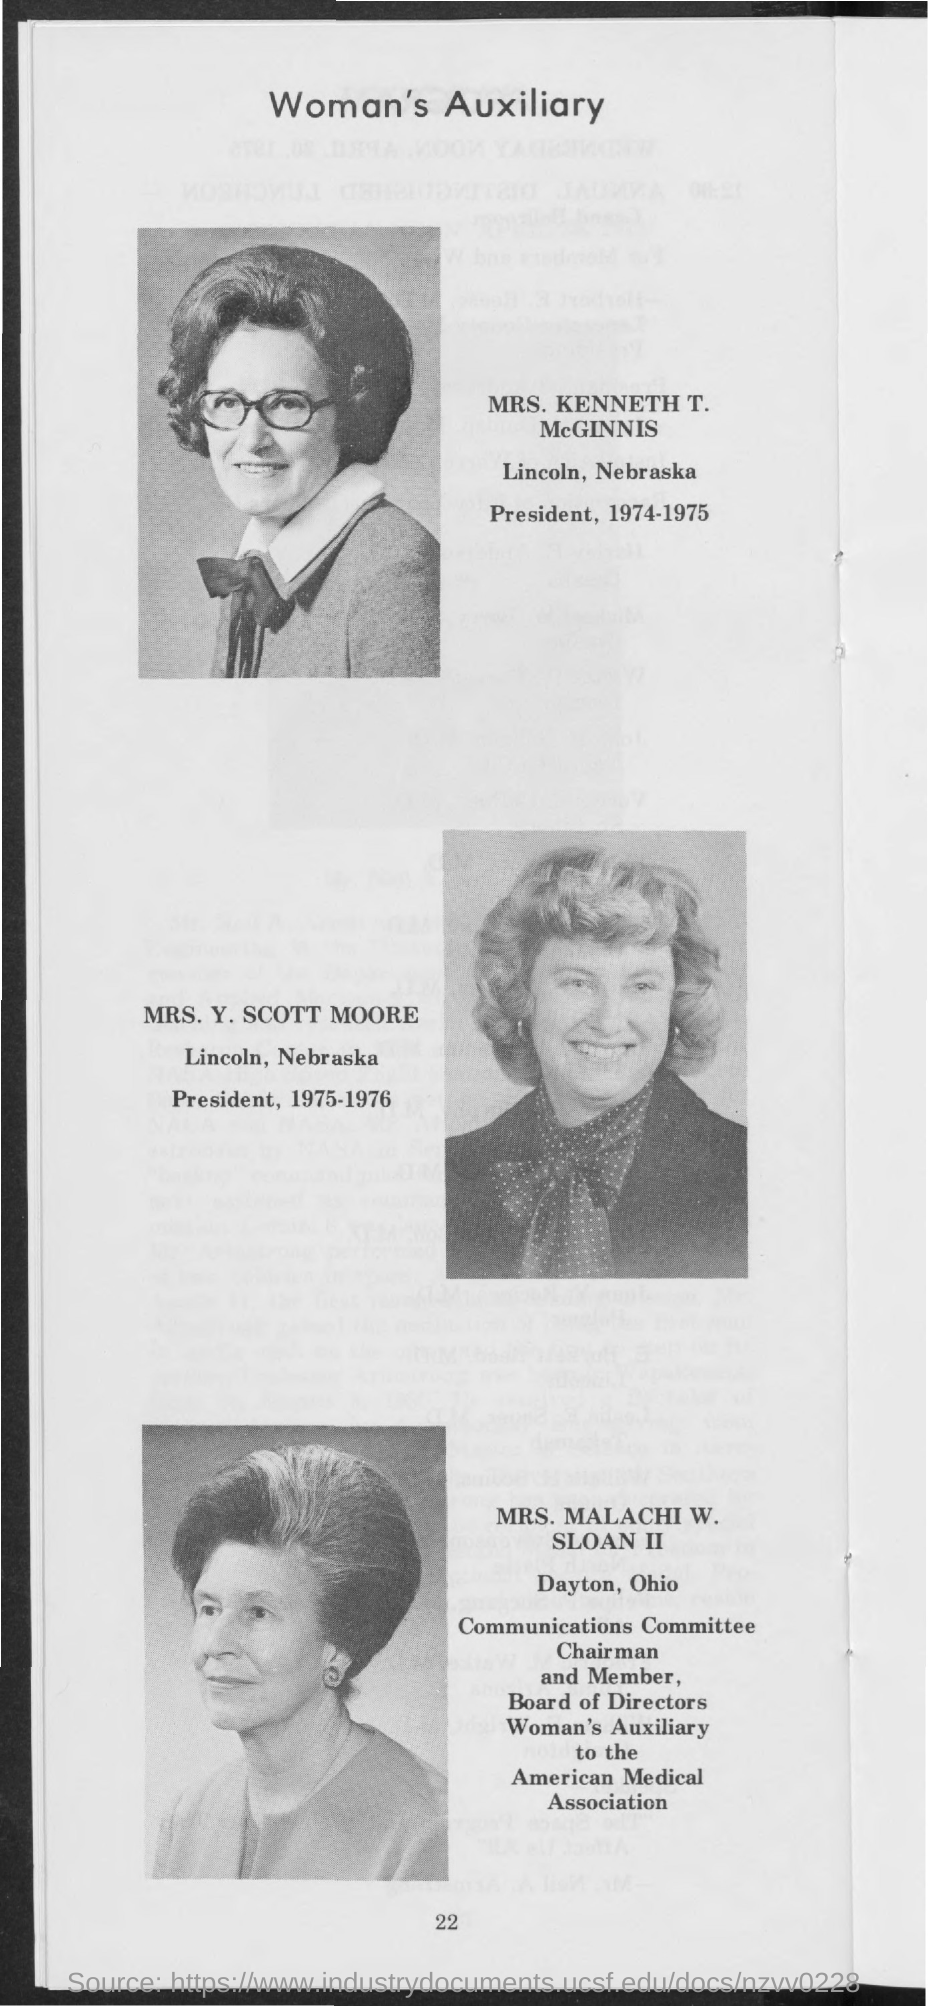List a handful of essential elements in this visual. During the year 1974-1975, Mrs. Kenneth T. McGinnis served as the President of Lincoln, Nebraska. During the year 1975-1976, Mrs. Y. Scott Moore served as the President of Lincoln, Nebraska. 